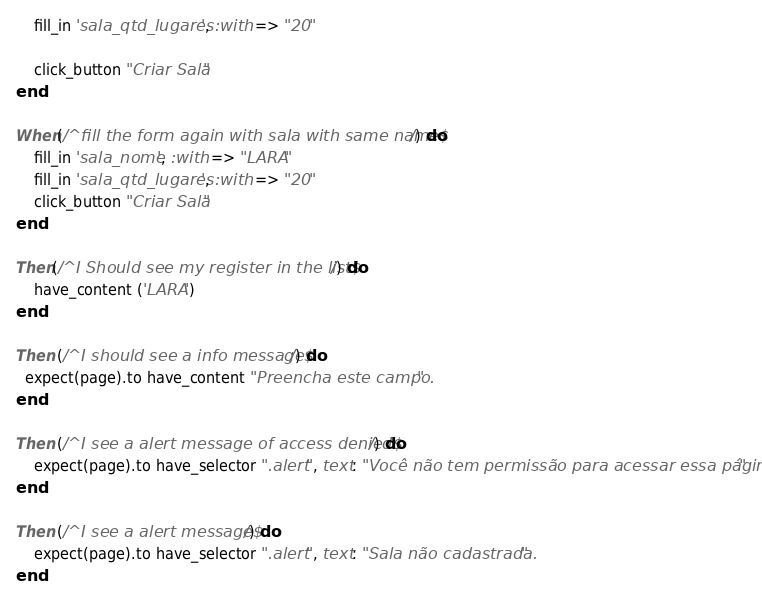<code> <loc_0><loc_0><loc_500><loc_500><_Ruby_>	fill_in 'sala_qtd_lugares', :with => "20"
	
	click_button "Criar Sala"
end

When(/^fill the form again with sala with same name$/) do
	fill_in 'sala_nome', :with => "LARA"
	fill_in 'sala_qtd_lugares', :with => "20"
	click_button "Criar Sala"
end

Then(/^I Should see my register in the list$/) do
	have_content ('LARA')
end

Then (/^I should see a info message$/) do
  expect(page).to have_content "Preencha este campo."
end

Then (/^I see a alert message of access denied$/) do
	expect(page).to have_selector ".alert", text: "Você não tem permissão para acessar essa página."
end

Then (/^I see a alert message$/) do
	expect(page).to have_selector ".alert", text: "Sala não cadastrada."
end

</code> 